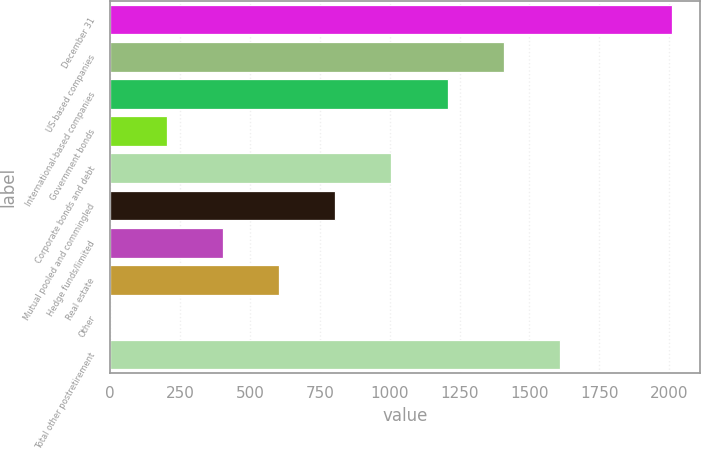<chart> <loc_0><loc_0><loc_500><loc_500><bar_chart><fcel>December 31<fcel>US-based companies<fcel>International-based companies<fcel>Government bonds<fcel>Corporate bonds and debt<fcel>Mutual pooled and commingled<fcel>Hedge funds/limited<fcel>Real estate<fcel>Other<fcel>Total other postretirement<nl><fcel>2011<fcel>1408<fcel>1207<fcel>202<fcel>1006<fcel>805<fcel>403<fcel>604<fcel>1<fcel>1609<nl></chart> 